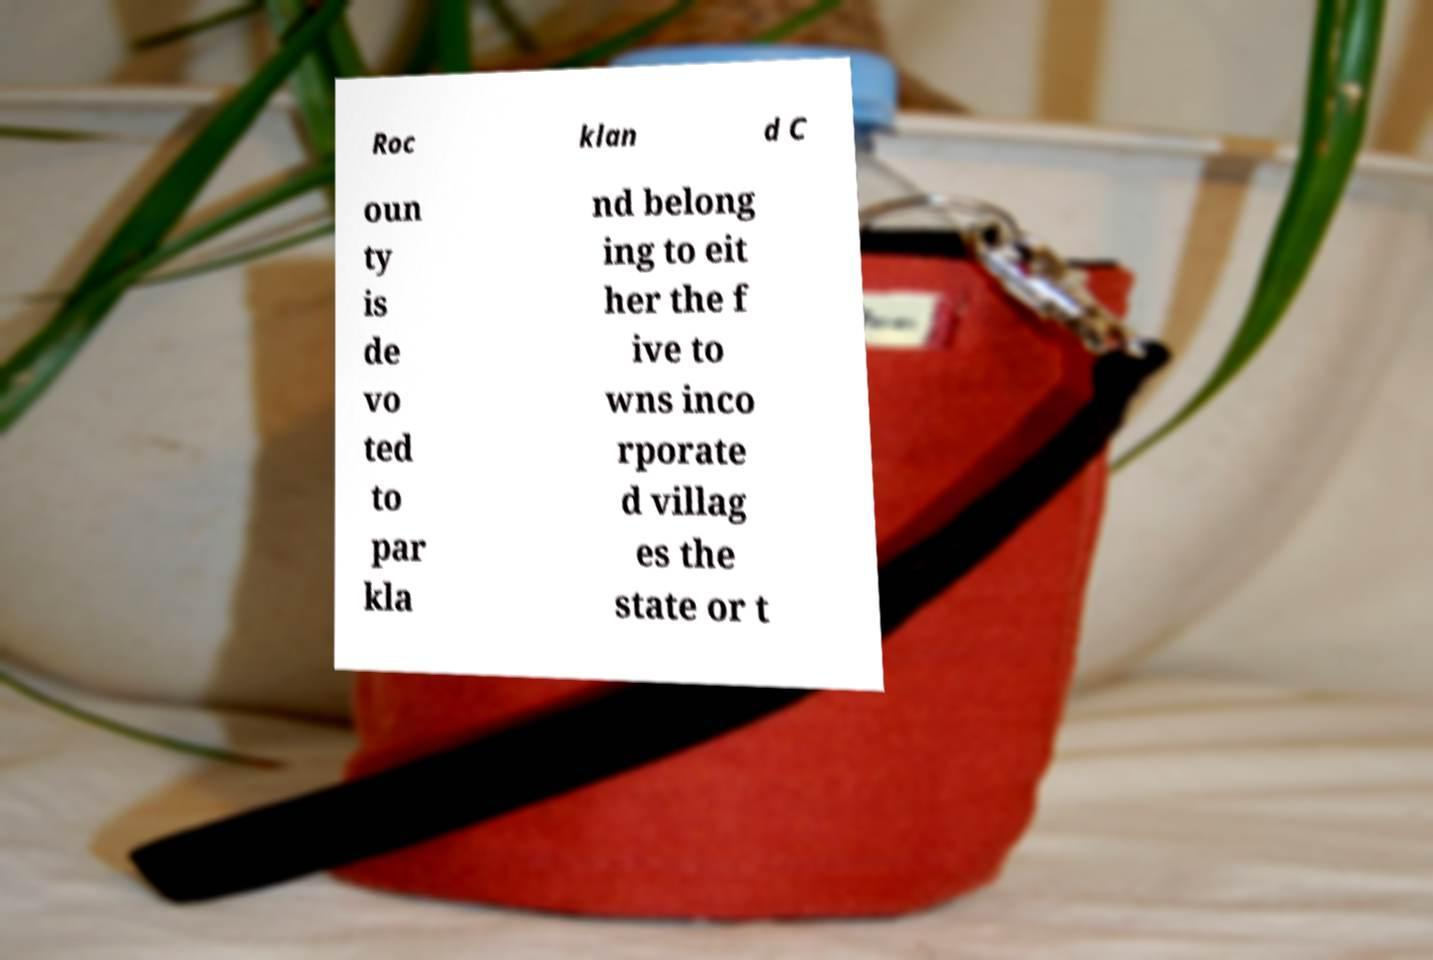What messages or text are displayed in this image? I need them in a readable, typed format. Roc klan d C oun ty is de vo ted to par kla nd belong ing to eit her the f ive to wns inco rporate d villag es the state or t 